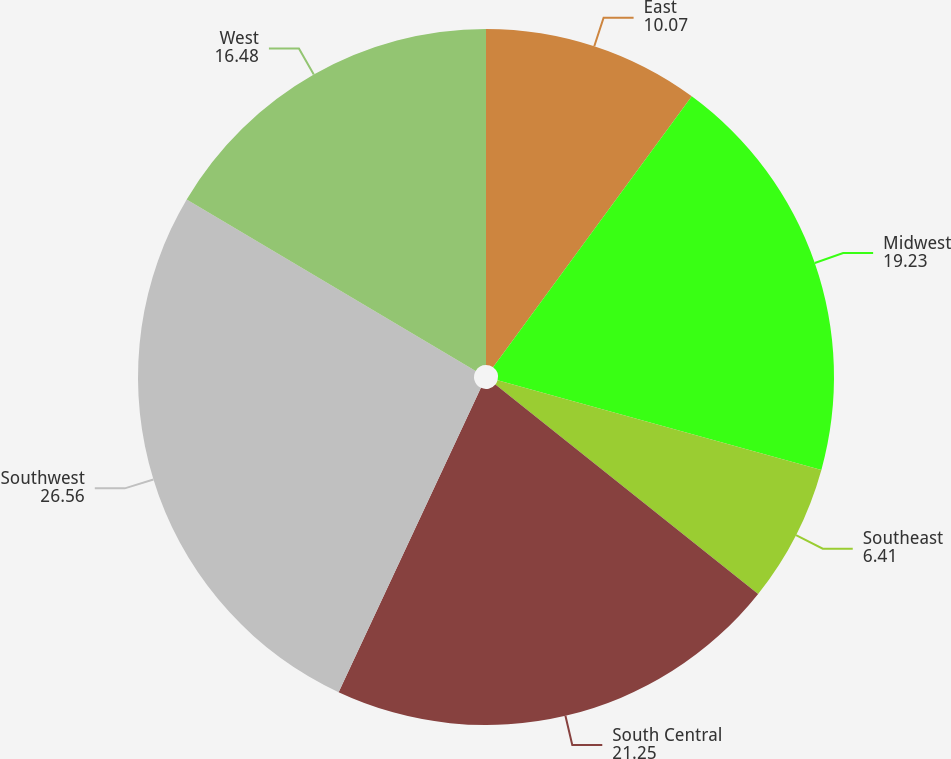<chart> <loc_0><loc_0><loc_500><loc_500><pie_chart><fcel>East<fcel>Midwest<fcel>Southeast<fcel>South Central<fcel>Southwest<fcel>West<nl><fcel>10.07%<fcel>19.23%<fcel>6.41%<fcel>21.25%<fcel>26.56%<fcel>16.48%<nl></chart> 